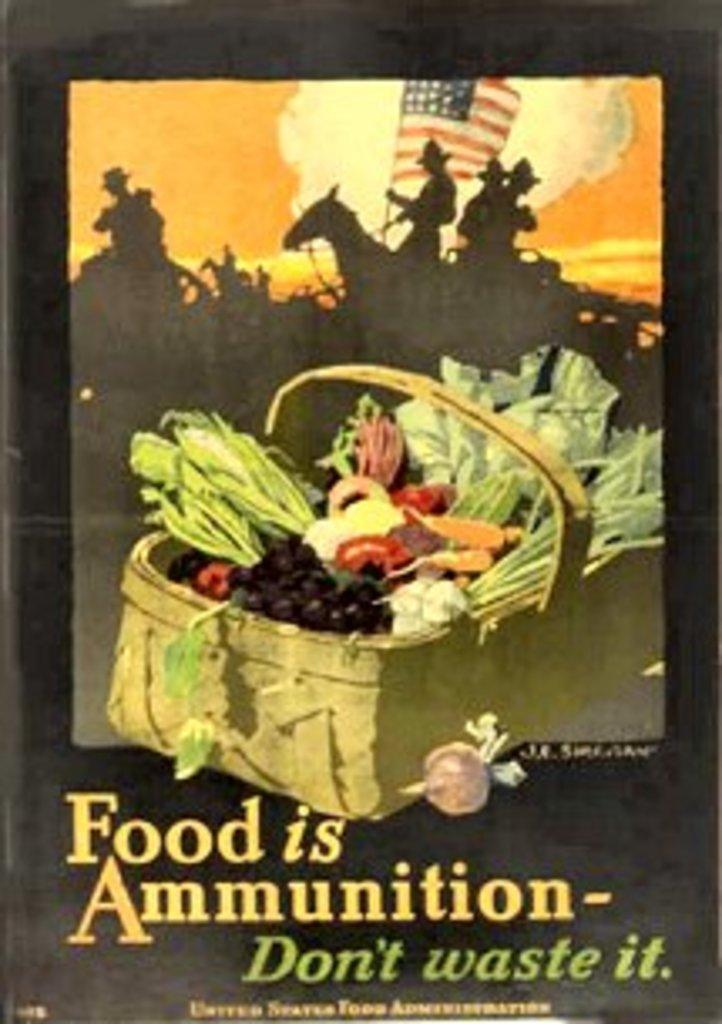<image>
Give a short and clear explanation of the subsequent image. A poster that proclaims that Food is Ammunition and says not to waste it 